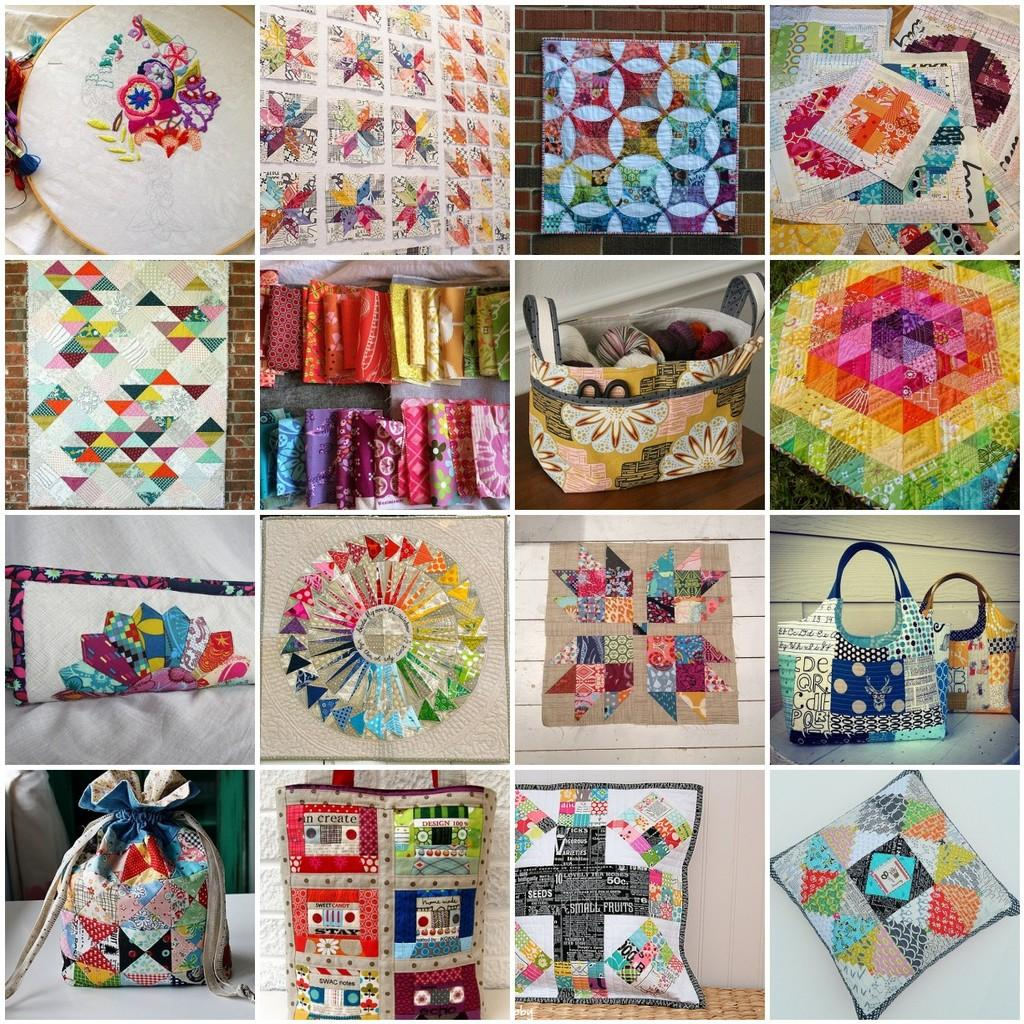What type of artwork is depicted in the image? The image is a collage. What can be found within the collage? The collage contains different handcrafted items. What types of toys are included in the collage? There is no mention of toys in the image or the provided facts, so we cannot determine if any toys are included in the collage. 